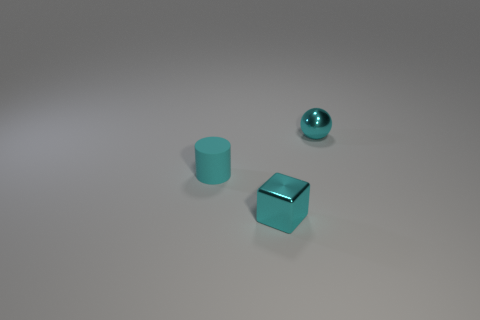Add 1 metal spheres. How many objects exist? 4 Subtract 1 spheres. How many spheres are left? 0 Subtract all green blocks. Subtract all brown cylinders. How many blocks are left? 1 Subtract all metal blocks. Subtract all shiny objects. How many objects are left? 0 Add 3 tiny matte objects. How many tiny matte objects are left? 4 Add 2 small cyan cubes. How many small cyan cubes exist? 3 Subtract 1 cyan balls. How many objects are left? 2 